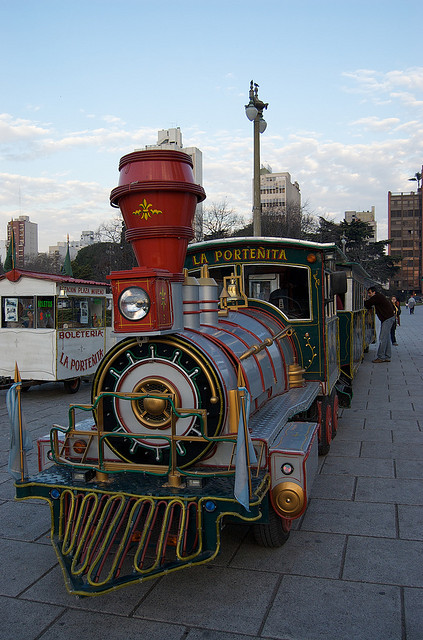Identify the text contained in this image. LA PORTENITA BOLETERIK LA 